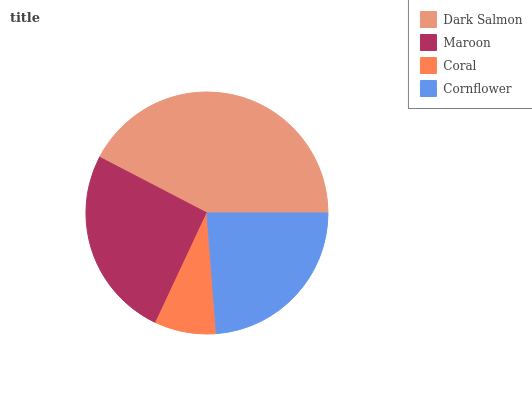Is Coral the minimum?
Answer yes or no. Yes. Is Dark Salmon the maximum?
Answer yes or no. Yes. Is Maroon the minimum?
Answer yes or no. No. Is Maroon the maximum?
Answer yes or no. No. Is Dark Salmon greater than Maroon?
Answer yes or no. Yes. Is Maroon less than Dark Salmon?
Answer yes or no. Yes. Is Maroon greater than Dark Salmon?
Answer yes or no. No. Is Dark Salmon less than Maroon?
Answer yes or no. No. Is Maroon the high median?
Answer yes or no. Yes. Is Cornflower the low median?
Answer yes or no. Yes. Is Dark Salmon the high median?
Answer yes or no. No. Is Dark Salmon the low median?
Answer yes or no. No. 